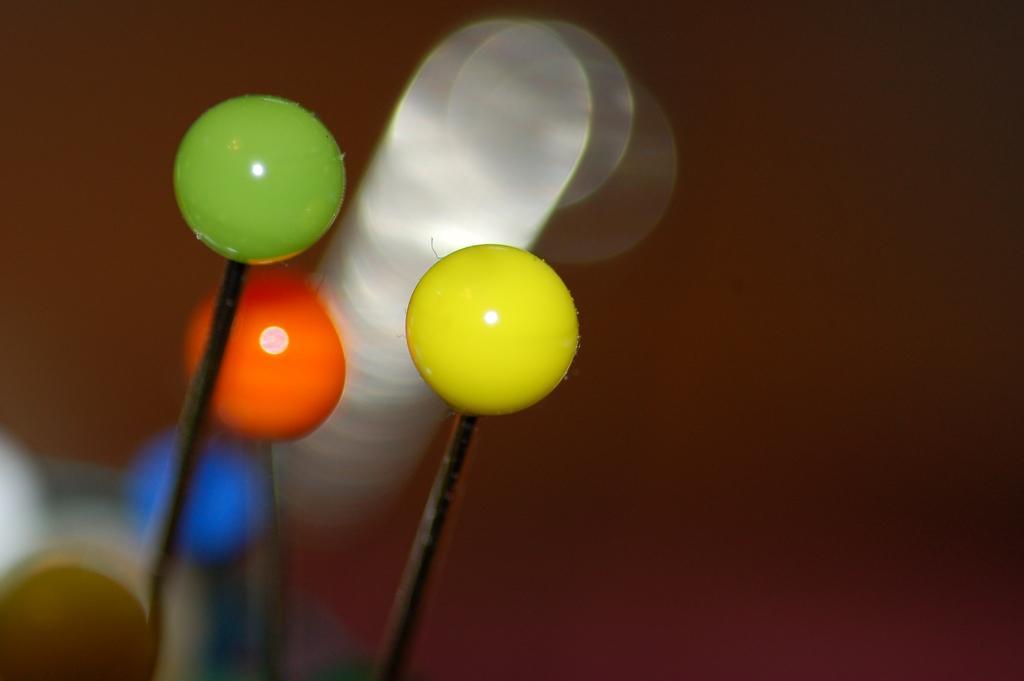Could you give a brief overview of what you see in this image? In the picture I can see few objects which are in round shape are attached to a black object and there are few other objects in the background. 